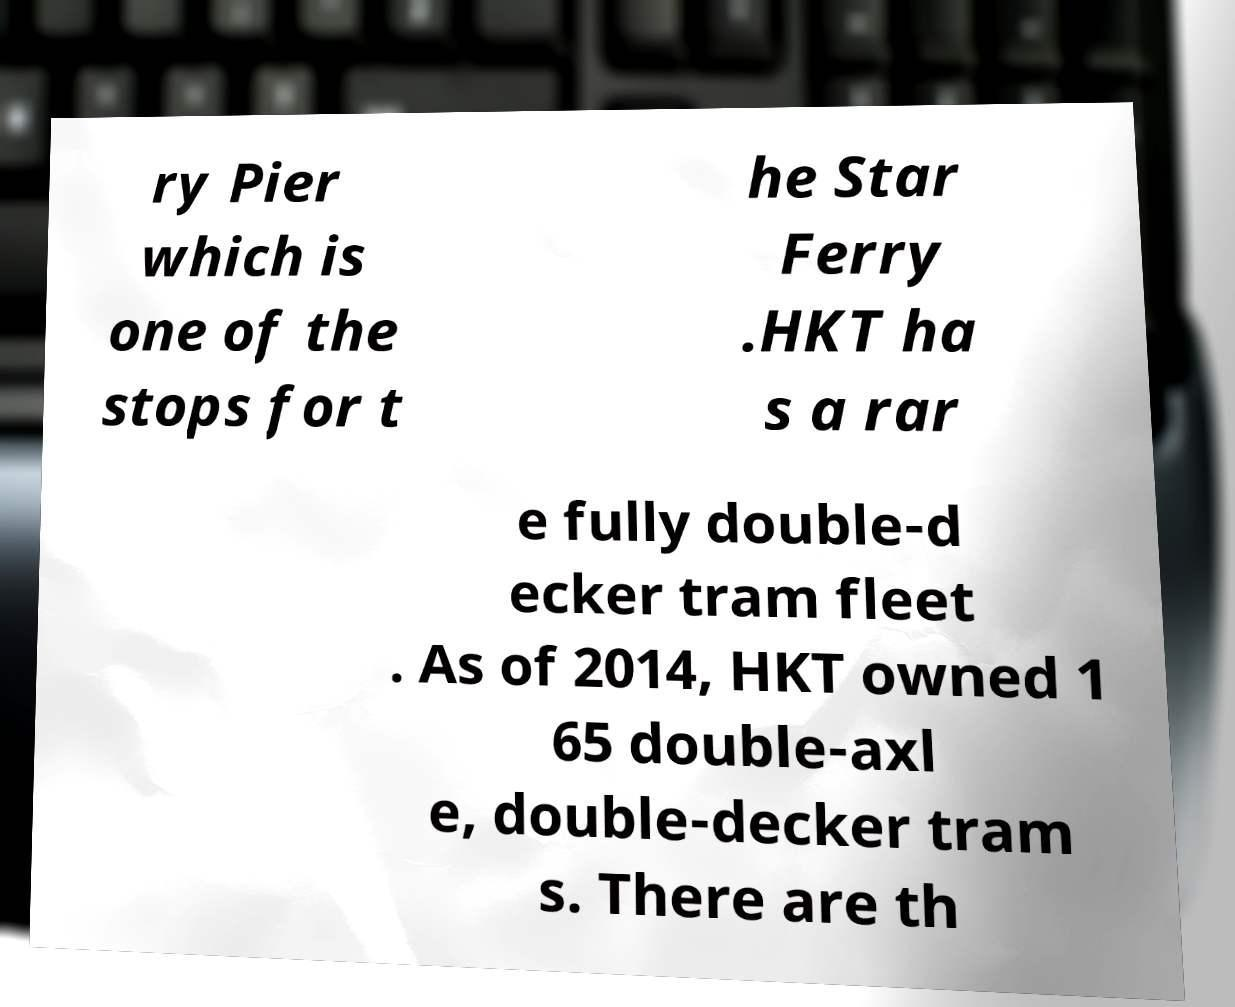Please read and relay the text visible in this image. What does it say? ry Pier which is one of the stops for t he Star Ferry .HKT ha s a rar e fully double-d ecker tram fleet . As of 2014, HKT owned 1 65 double-axl e, double-decker tram s. There are th 